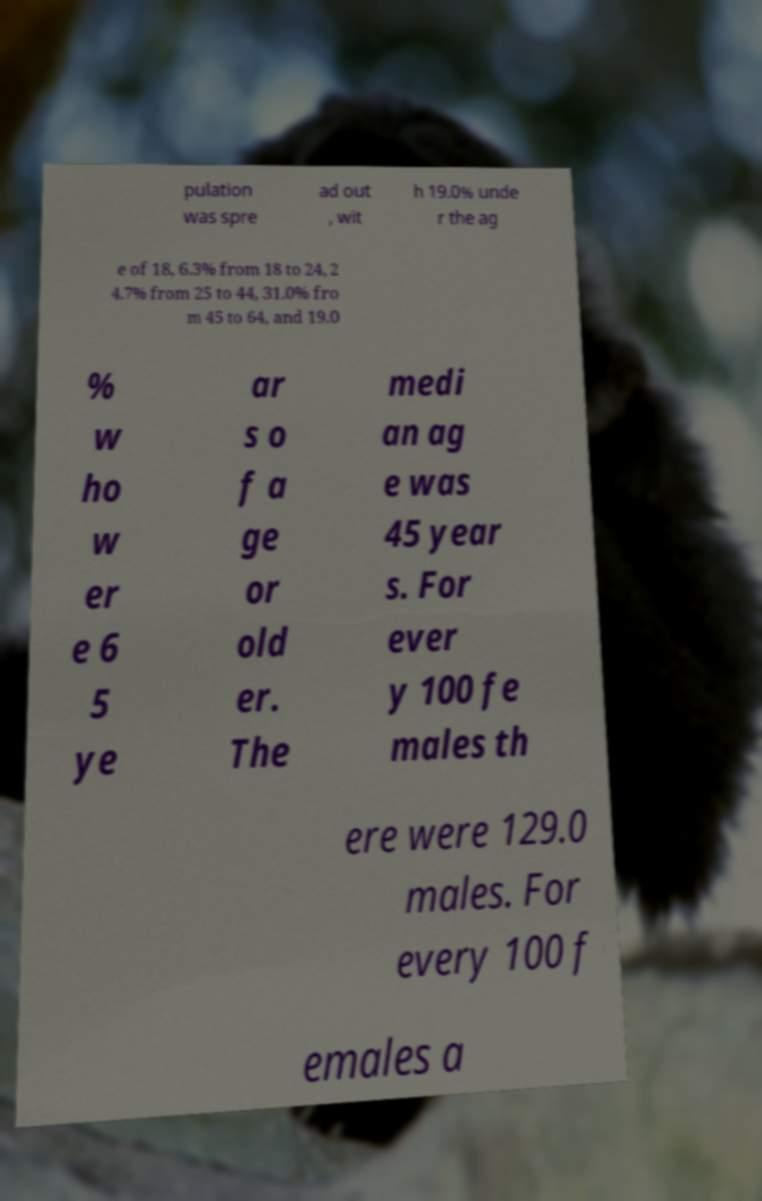I need the written content from this picture converted into text. Can you do that? pulation was spre ad out , wit h 19.0% unde r the ag e of 18, 6.3% from 18 to 24, 2 4.7% from 25 to 44, 31.0% fro m 45 to 64, and 19.0 % w ho w er e 6 5 ye ar s o f a ge or old er. The medi an ag e was 45 year s. For ever y 100 fe males th ere were 129.0 males. For every 100 f emales a 